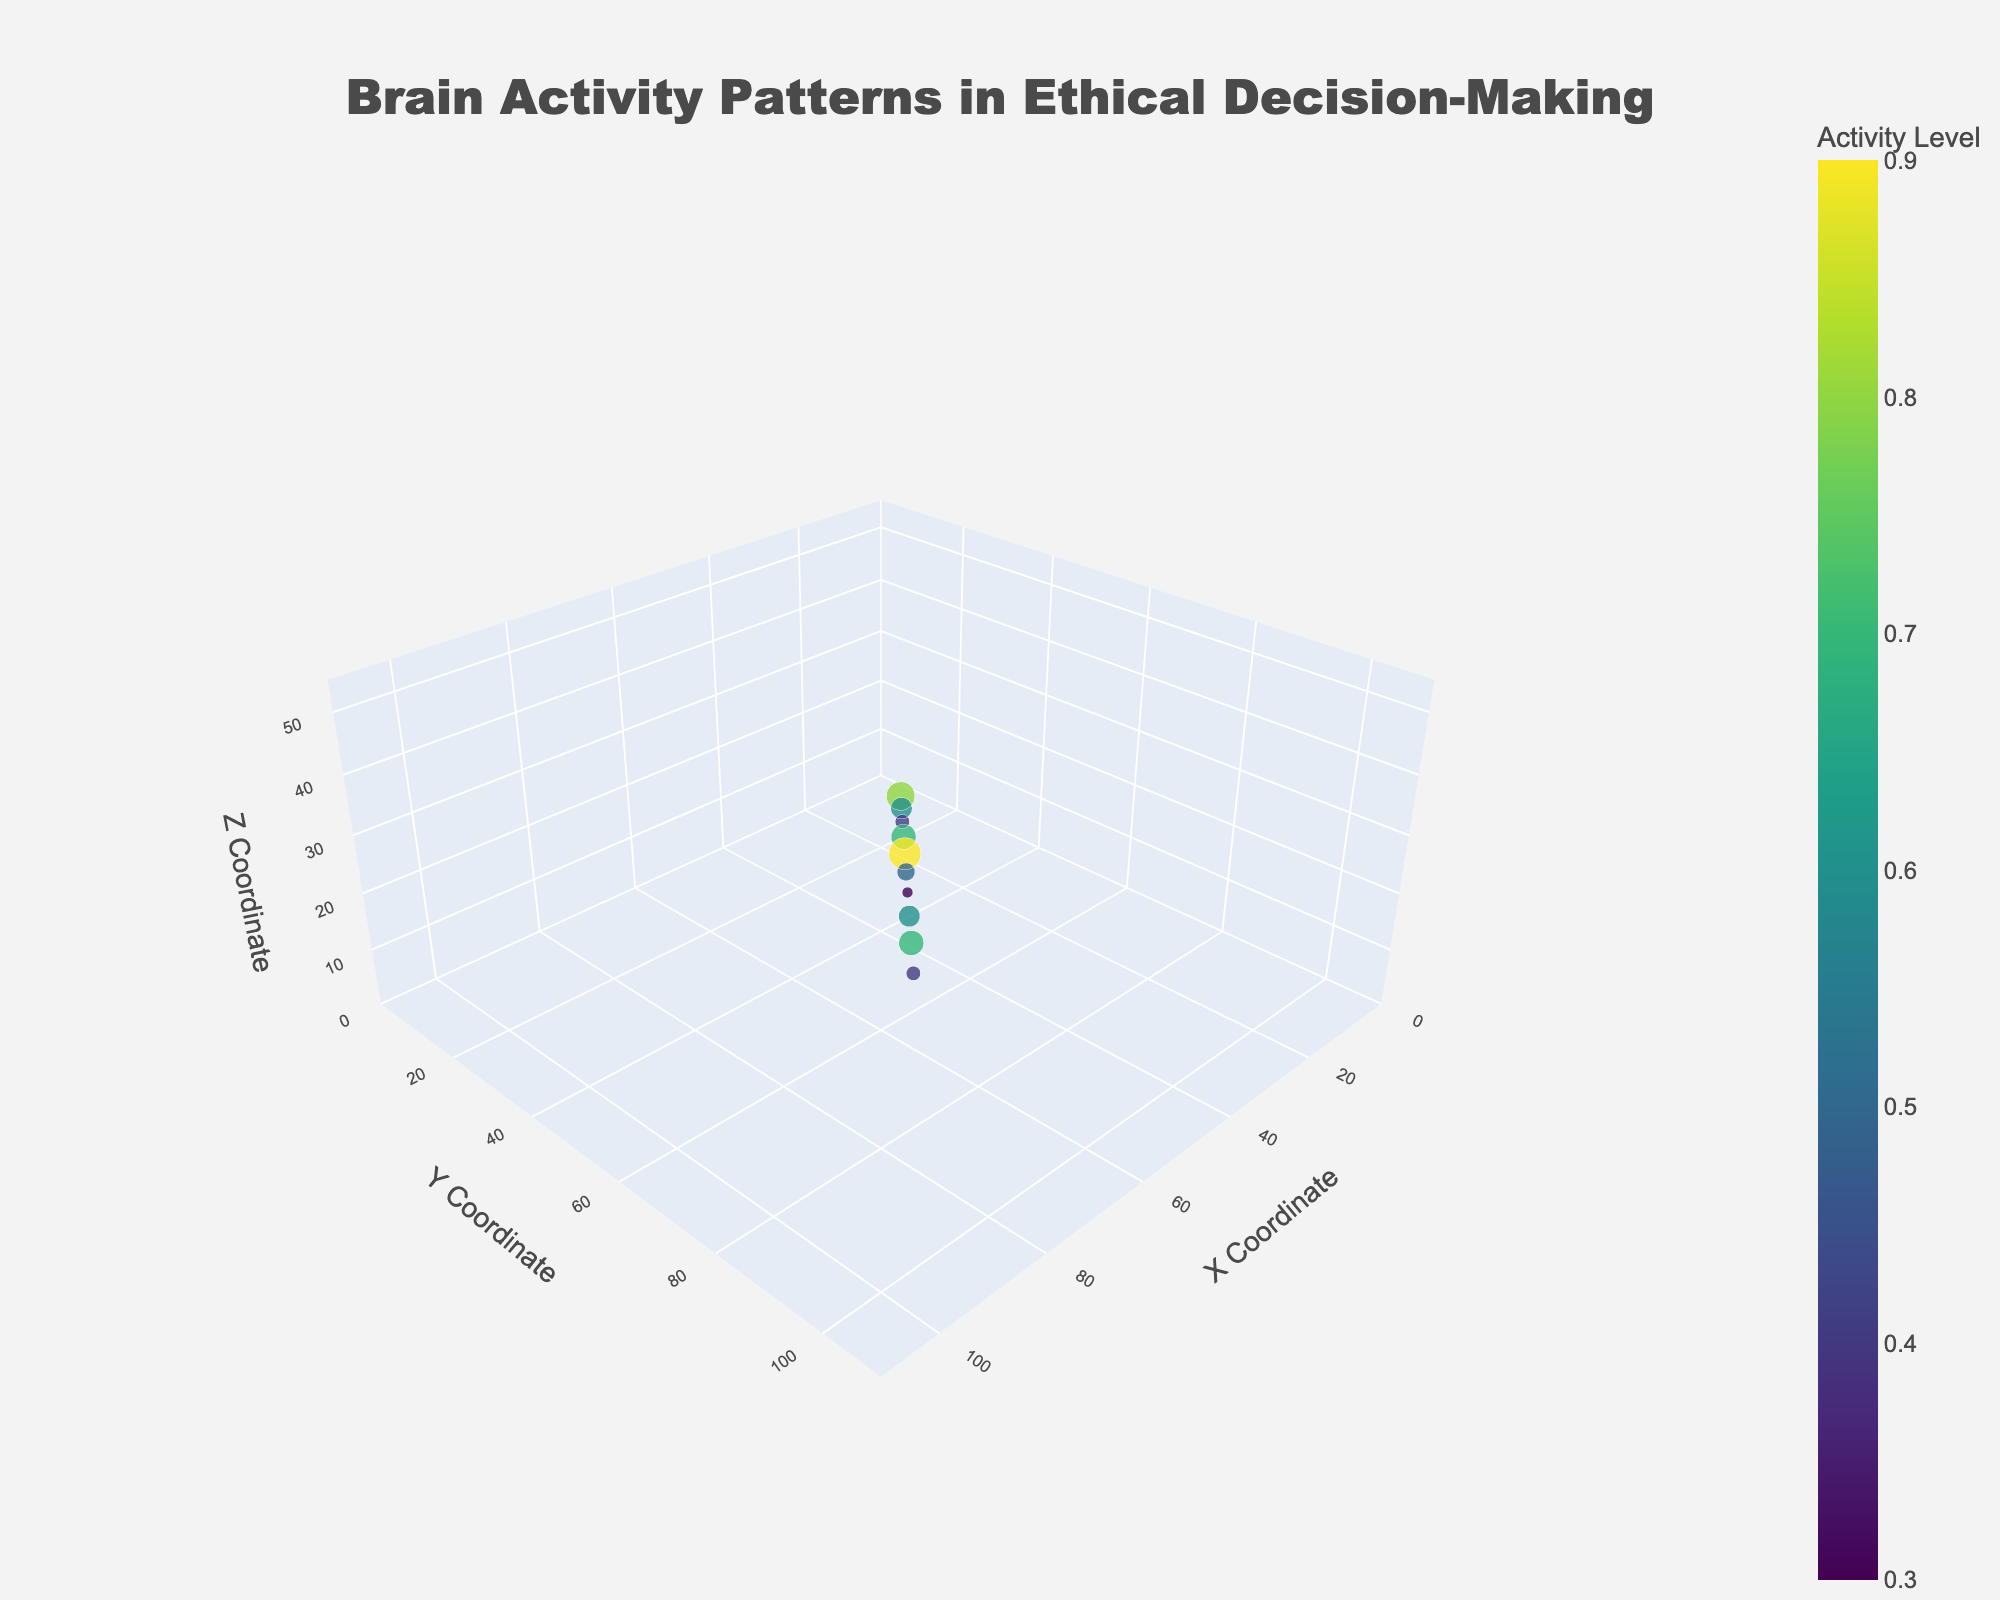What is the title of the plot? The title of a plot is usually displayed prominently at the top of the figure, providing a brief description of the data being visualized. In this case, the title is "Brain Activity Patterns in Ethical Decision-Making."
Answer: Brain Activity Patterns in Ethical Decision-Making What are the axis labels in the 3D plot? The axis labels in a 3D plot typically describe what each axis represents. Here, they are "X Coordinate" for the x-axis, "Y Coordinate" for the y-axis, and "Z Coordinate" for the z-axis.
Answer: X Coordinate, Y Coordinate, Z Coordinate How many data points represent the activity levels in the brain regions? By examining the plot and counting the markers, each representing a data point, we can determine the number of brain regions visualized. In this figure, there are 10 data points.
Answer: 10 Which brain region has the highest activity level during ethical decision-making tasks, and what is the decision type associated with it? The size and color intensity of the markers indicate activity levels. The largest and most intensely colored marker corresponds to the highest activity level. From the plot, it is evident that the Dorsolateral Prefrontal Cortex shows the highest activity level of 0.9, associated with "Rational Deliberation."
Answer: Dorsolateral Prefrontal Cortex, Rational Deliberation Compare the activity levels of the Prefrontal Cortex during 'Moral Dilemma' and the Orbitofrontal Cortex during 'Reward Evaluation'. Which one is higher? To compare activity levels, look at the respective markers for both brain regions. The Prefrontal Cortex has an activity level of 0.8, while the Orbitofrontal Cortex has an activity level of 0.7. Thus, the Prefrontal Cortex has a higher activity level.
Answer: Prefrontal Cortex What is the average activity level across all brain regions? To find the average, sum all activity levels and divide by the number of regions. Activity levels: 0.8, 0.6, 0.4, 0.7, 0.9, 0.5, 0.3, 0.6, 0.7, 0.4. Sum: 0.8 + 0.6 + 0.4 + 0.7 + 0.9 + 0.5 + 0.3 + 0.6 + 0.7 + 0.4 = 5.9. Average: 5.9 / 10 = 0.59.
Answer: 0.59 Which brain region is associated with the decision type 'Value-based Decision' and what is its activity level? From the plot, locate the marker with 'Value-based Decision' in its hover text. This corresponds to the Ventromedial Prefrontal Cortex, with an activity level of 0.5.
Answer: Ventromedial Prefrontal Cortex, 0.5 What is the spatial range covered along the x, y, and z axes? The axis ranges can be deduced from the extremes visible in the plot. For the x-axis, the range is from 0 to 110; for the y-axis, from 0 to 110; and for the z-axis, from 0 to 55.
Answer: x: 0–110, y: 0–110, z: 0–55 